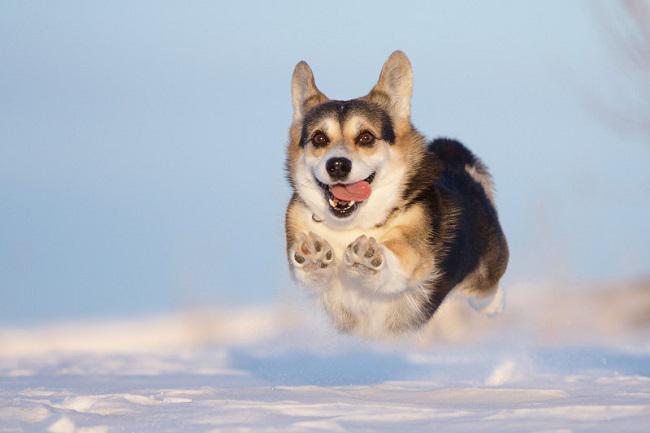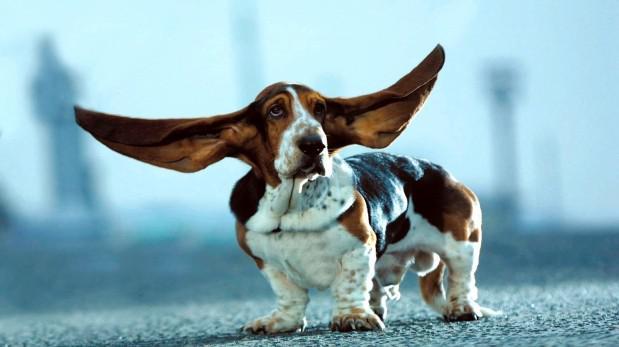The first image is the image on the left, the second image is the image on the right. For the images displayed, is the sentence "In at least one image there is  a corgi white a black belly jumping in the are with it tongue wagging" factually correct? Answer yes or no. Yes. The first image is the image on the left, the second image is the image on the right. For the images shown, is this caption "One dog is in snow." true? Answer yes or no. Yes. 